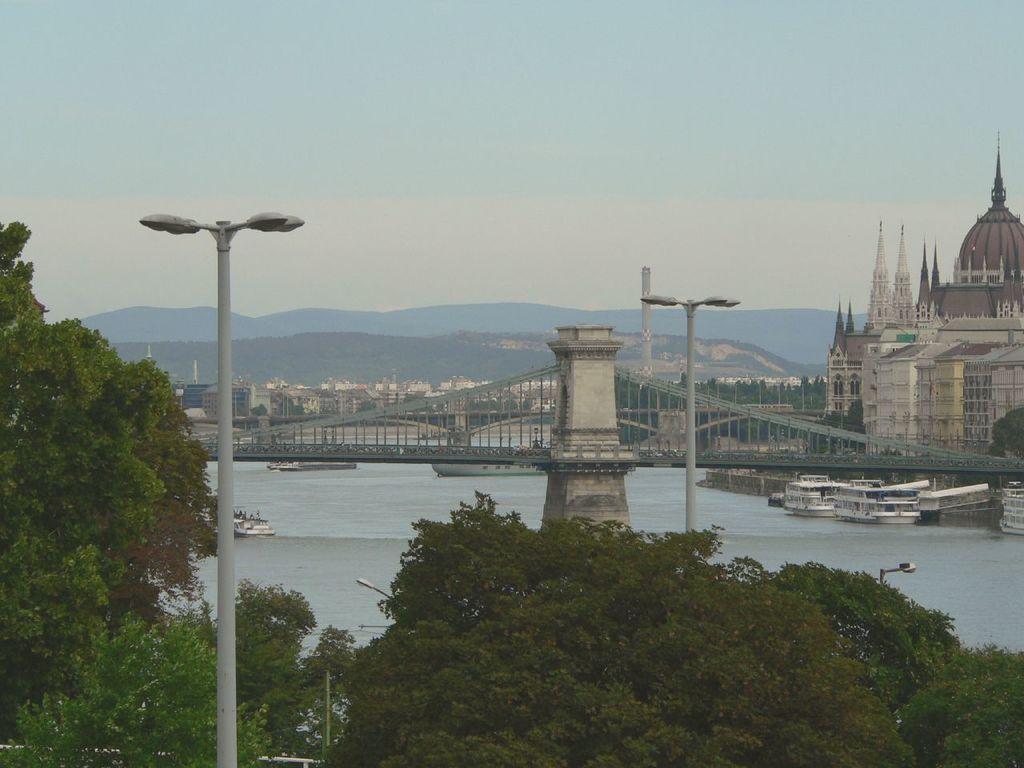Describe this image in one or two sentences. This is an outside view. At the bottom there are many trees and also there are few light poles. In the middle of the image there is a tower and I can see few boats on the water and also there is a bridge. In the background there are buildings, trees and hills. At the top of the image I can see the sky. 